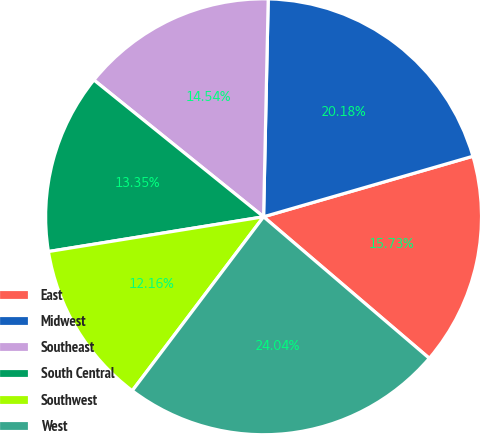Convert chart. <chart><loc_0><loc_0><loc_500><loc_500><pie_chart><fcel>East<fcel>Midwest<fcel>Southeast<fcel>South Central<fcel>Southwest<fcel>West<nl><fcel>15.73%<fcel>20.18%<fcel>14.54%<fcel>13.35%<fcel>12.16%<fcel>24.04%<nl></chart> 